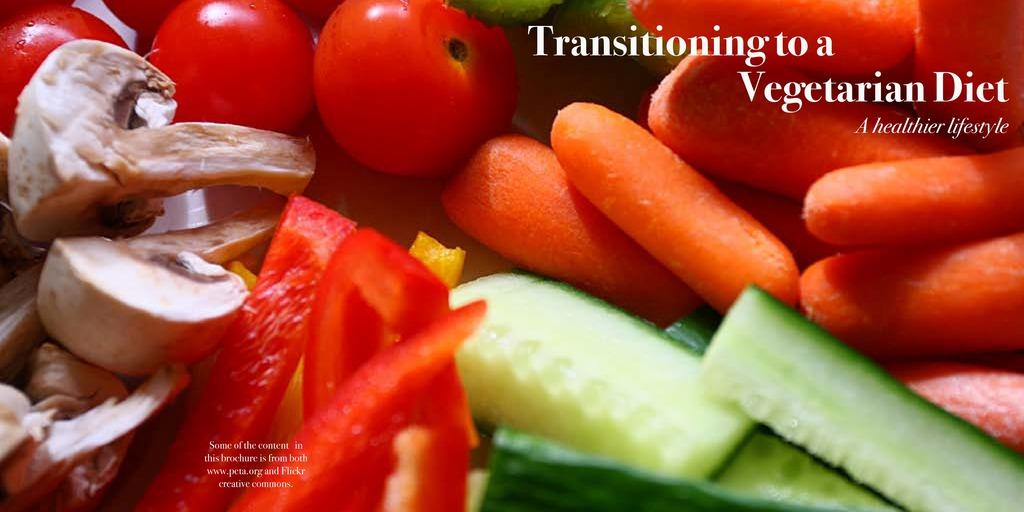What type of food items can be seen in the image? There are vegetables, tomatoes, mushrooms, and carrots in the image. Can you describe the specific vegetables present in the image? Yes, there are tomatoes, mushrooms, and carrots in the image. Are there any words visible in the image? Yes, there are white color words on the image. How many chickens are present on the island in the image? There are no chickens or islands present in the image; it features vegetables and color words. What order are the vegetables arranged in the image? The vegetables are not arranged in any specific order in the image; they are simply visible. 